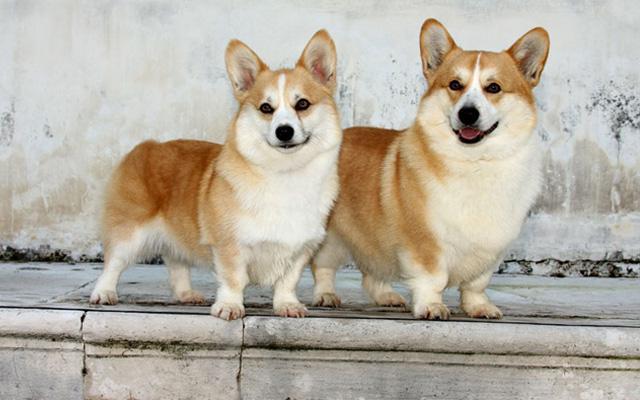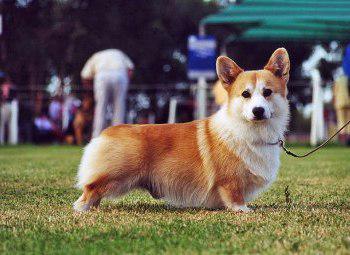The first image is the image on the left, the second image is the image on the right. For the images displayed, is the sentence "All dogs are standing on all fours with their bodies aimed rightward, and at least one dog has its head turned to face the camera." factually correct? Answer yes or no. Yes. The first image is the image on the left, the second image is the image on the right. Given the left and right images, does the statement "There are exactly two dogs and both of them are outdoors." hold true? Answer yes or no. No. 